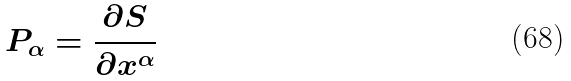<formula> <loc_0><loc_0><loc_500><loc_500>P _ { \alpha } = \frac { \partial S } { \partial x ^ { \alpha } }</formula> 